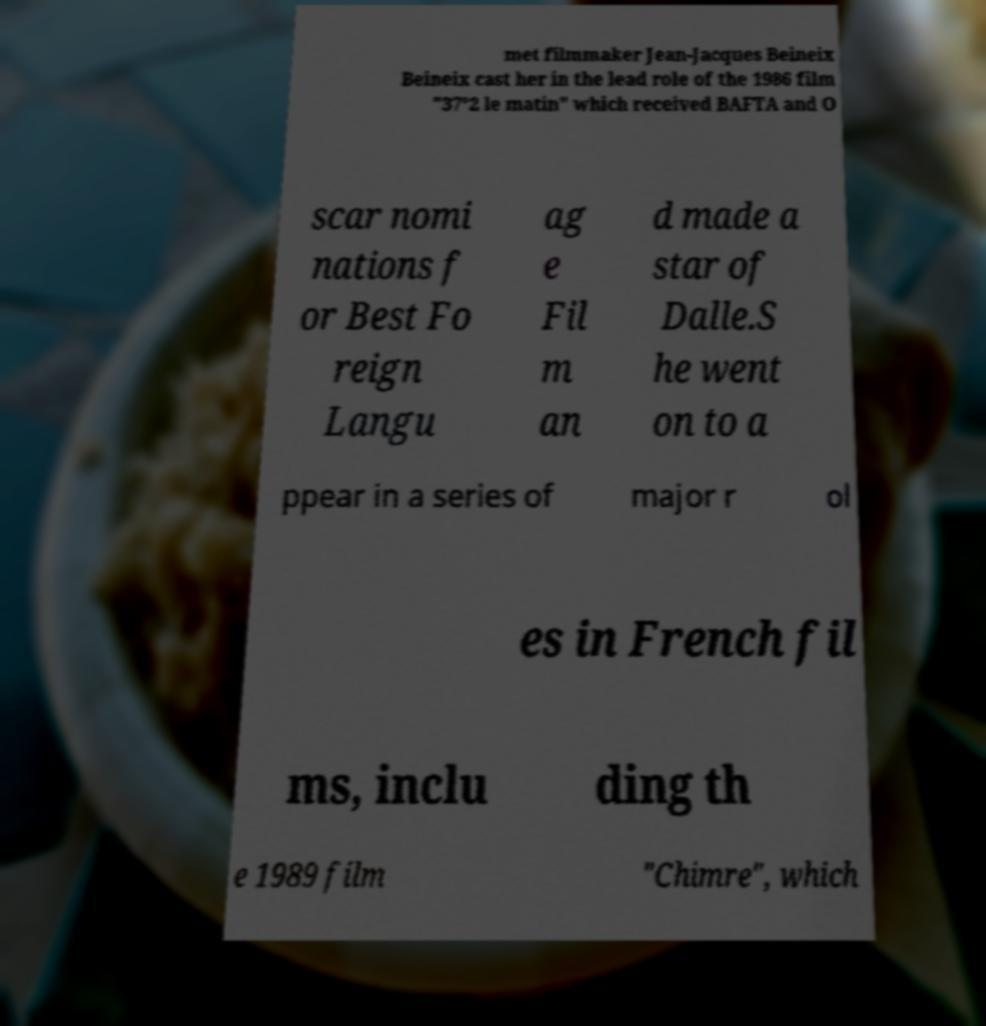Please identify and transcribe the text found in this image. met filmmaker Jean-Jacques Beineix Beineix cast her in the lead role of the 1986 film "37°2 le matin" which received BAFTA and O scar nomi nations f or Best Fo reign Langu ag e Fil m an d made a star of Dalle.S he went on to a ppear in a series of major r ol es in French fil ms, inclu ding th e 1989 film "Chimre", which 